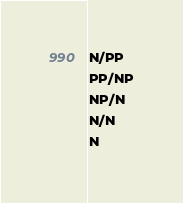<code> <loc_0><loc_0><loc_500><loc_500><_C_>N/PP
PP/NP
NP/N
N/N
N
</code> 